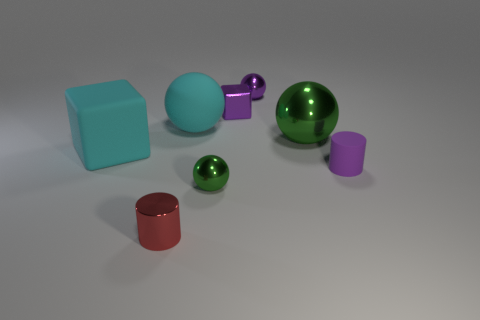Add 2 purple matte cylinders. How many objects exist? 10 Subtract all cylinders. How many objects are left? 6 Subtract all big cyan matte cubes. Subtract all big yellow things. How many objects are left? 7 Add 5 large green spheres. How many large green spheres are left? 6 Add 8 cyan rubber objects. How many cyan rubber objects exist? 10 Subtract 0 cyan cylinders. How many objects are left? 8 